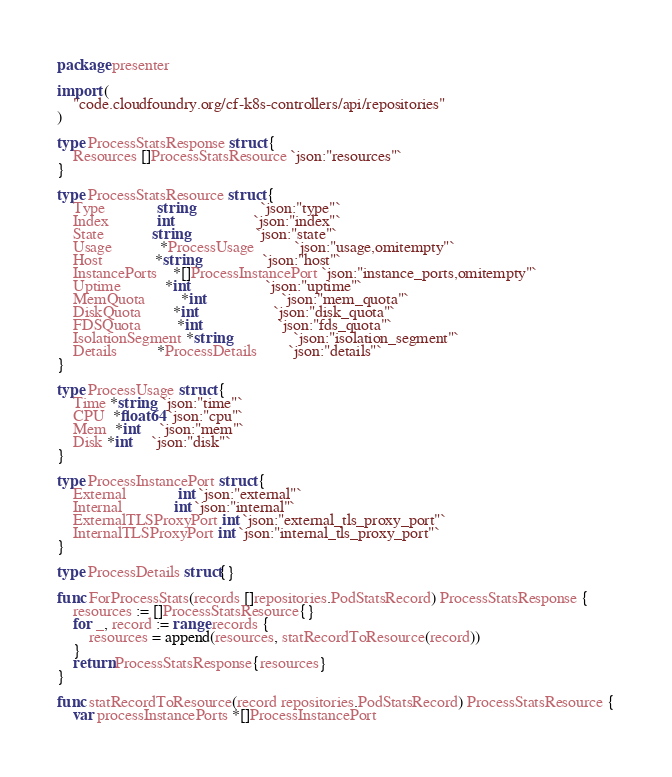<code> <loc_0><loc_0><loc_500><loc_500><_Go_>package presenter

import (
	"code.cloudfoundry.org/cf-k8s-controllers/api/repositories"
)

type ProcessStatsResponse struct {
	Resources []ProcessStatsResource `json:"resources"`
}

type ProcessStatsResource struct {
	Type             string                 `json:"type"`
	Index            int                    `json:"index"`
	State            string                 `json:"state"`
	Usage            *ProcessUsage          `json:"usage,omitempty"`
	Host             *string                `json:"host"`
	InstancePorts    *[]ProcessInstancePort `json:"instance_ports,omitempty"`
	Uptime           *int                   `json:"uptime"`
	MemQuota         *int                   `json:"mem_quota"`
	DiskQuota        *int                   `json:"disk_quota"`
	FDSQuota         *int                   `json:"fds_quota"`
	IsolationSegment *string                `json:"isolation_segment"`
	Details          *ProcessDetails        `json:"details"`
}

type ProcessUsage struct {
	Time *string  `json:"time"`
	CPU  *float64 `json:"cpu"`
	Mem  *int     `json:"mem"`
	Disk *int     `json:"disk"`
}

type ProcessInstancePort struct {
	External             int `json:"external"`
	Internal             int `json:"internal"`
	ExternalTLSProxyPort int `json:"external_tls_proxy_port"`
	InternalTLSProxyPort int `json:"internal_tls_proxy_port"`
}

type ProcessDetails struct{}

func ForProcessStats(records []repositories.PodStatsRecord) ProcessStatsResponse {
	resources := []ProcessStatsResource{}
	for _, record := range records {
		resources = append(resources, statRecordToResource(record))
	}
	return ProcessStatsResponse{resources}
}

func statRecordToResource(record repositories.PodStatsRecord) ProcessStatsResource {
	var processInstancePorts *[]ProcessInstancePort</code> 